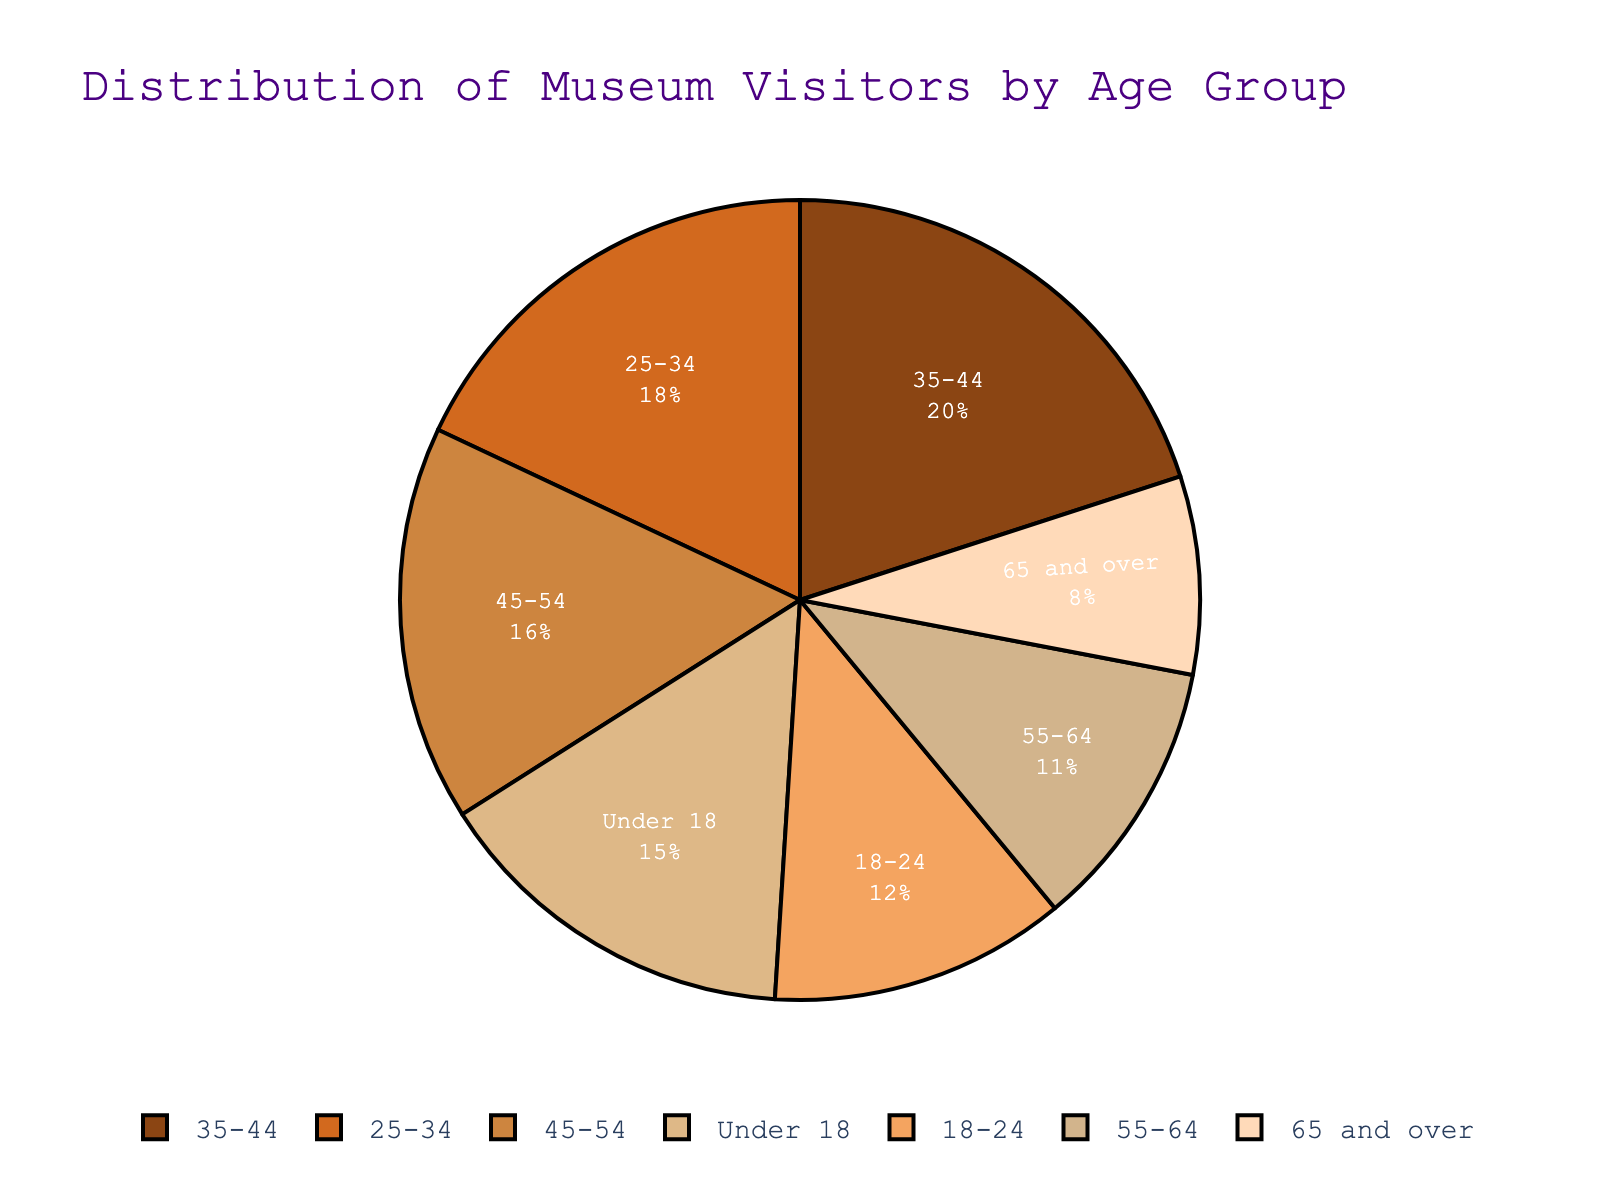What is the total percentage of museum visitors under the age of 35? To find the total percentage of museum visitors under 35, sum up the percentages of the age groups "Under 18", "18-24", and "25-34": 15% + 12% + 18% = 45%
Answer: 45% Which age group has the highest percentage of museum visitors? By looking at the pie chart, the "35-44" age group has the largest segment, indicating it has the highest percentage at 20%
Answer: 35-44 How does the percentage of visitors aged 45-54 compare to those aged 55-64? Compare the percentages: 16% for the 45-54 age group and 11% for the 55-64 age group; 16% is greater than 11%
Answer: 45-54 has more visitors What is the combined percentage of visitors aged 55 and over? Sum the percentages of the "55-64" and "65 and over" age groups: 11% + 8% = 19%
Answer: 19% Is the percentage of visitors aged 18-24 greater than those aged 65 and over? Compare the percentages: 12% for the 18-24 age group and 8% for the 65 and over age group; 12% is greater than 8%
Answer: Yes Which age group has the smallest percentage of museum visitors? The smallest segment in the pie chart is for the "65 and over" age group, which has a percentage of 8%
Answer: 65 and over What is the difference in the percentage of visitors between the 25-34 and 18-24 age groups? Subtract the percentage of the 18-24 age group from the percentage of the 25-34 age group: 18% - 12% = 6%
Answer: 6% What percentage of museum visitors are aged 35-54? Sum the percentages of the "35-44" and "45-54" age groups: 20% + 16% = 36%
Answer: 36% What are the colors of the segments representing people aged 18-24 and 55-64? The "18-24" age group segment is represented by a dark orange color and the "55-64" age group segment is represented by a light brown color
Answer: Dark orange and light brown 